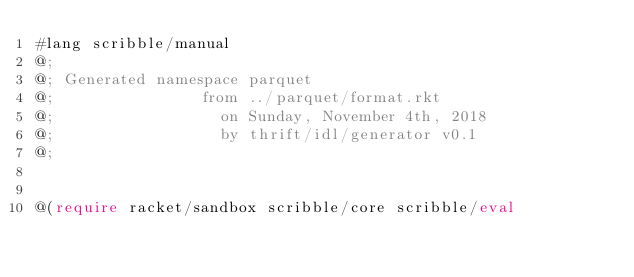<code> <loc_0><loc_0><loc_500><loc_500><_Racket_>#lang scribble/manual
@;
@; Generated namespace parquet
@;                from ../parquet/format.rkt
@;                  on Sunday, November 4th, 2018
@;                  by thrift/idl/generator v0.1
@;


@(require racket/sandbox scribble/core scribble/eval</code> 